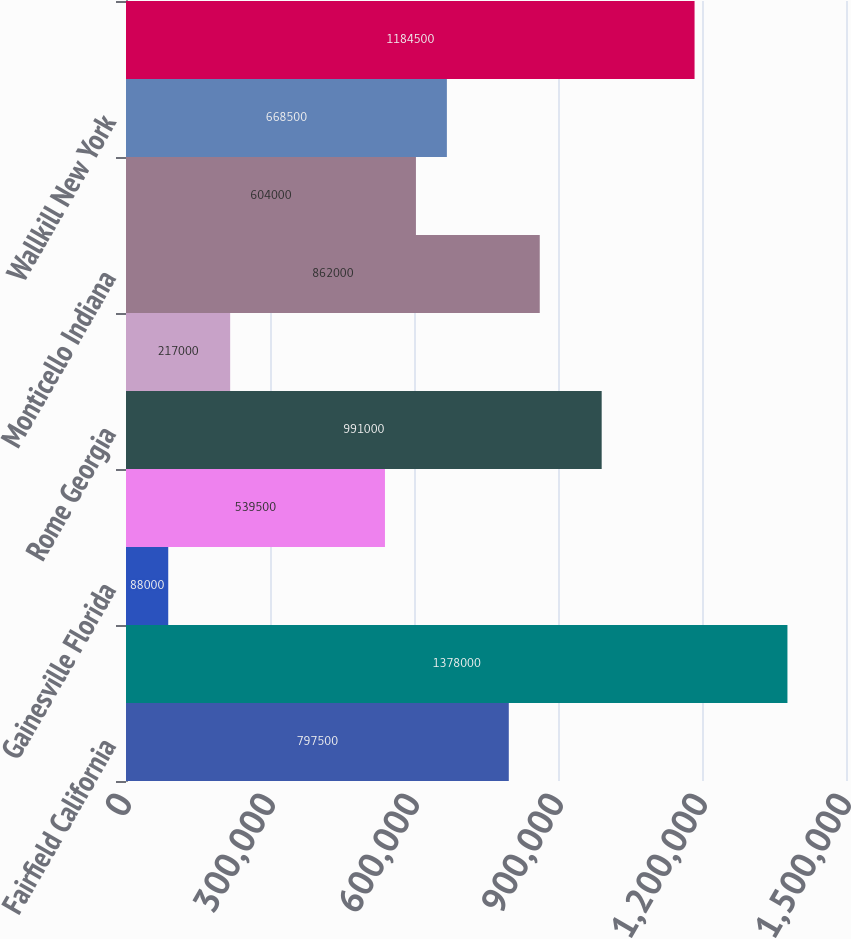Convert chart. <chart><loc_0><loc_0><loc_500><loc_500><bar_chart><fcel>Fairfield California<fcel>Golden Colorado<fcel>Gainesville Florida<fcel>Tampa Florida<fcel>Rome Georgia<fcel>Kapolei Hawaii<fcel>Monticello Indiana<fcel>Saratoga Springs New York<fcel>Wallkill New York<fcel>Reidsville North Carolina<nl><fcel>797500<fcel>1.378e+06<fcel>88000<fcel>539500<fcel>991000<fcel>217000<fcel>862000<fcel>604000<fcel>668500<fcel>1.1845e+06<nl></chart> 